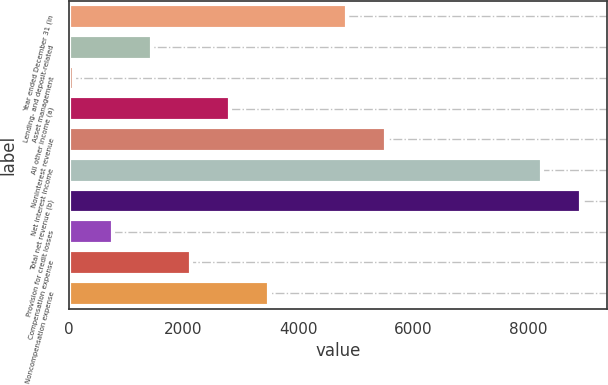Convert chart to OTSL. <chart><loc_0><loc_0><loc_500><loc_500><bar_chart><fcel>Year ended December 31 (in<fcel>Lending- and deposit-related<fcel>Asset management<fcel>All other income (a)<fcel>Noninterest revenue<fcel>Net interest income<fcel>Total net revenue (b)<fcel>Provision for credit losses<fcel>Compensation expense<fcel>Noncompensation expense<nl><fcel>4845<fcel>1450<fcel>92<fcel>2808<fcel>5524<fcel>8240<fcel>8919<fcel>771<fcel>2129<fcel>3487<nl></chart> 